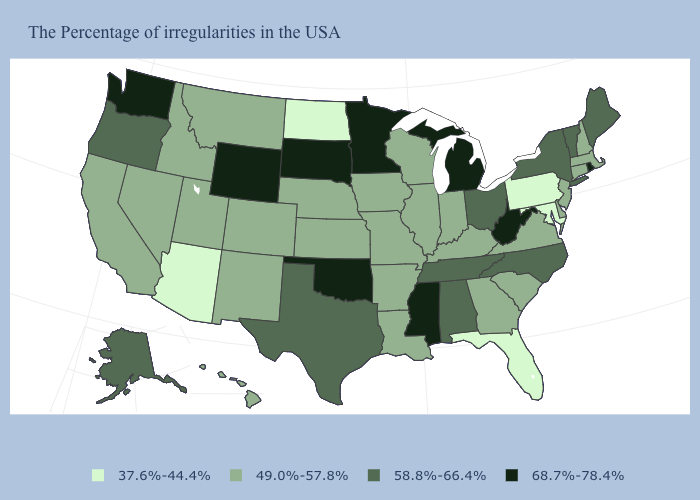What is the value of South Dakota?
Write a very short answer. 68.7%-78.4%. Among the states that border New Jersey , does New York have the highest value?
Short answer required. Yes. What is the highest value in the USA?
Be succinct. 68.7%-78.4%. What is the value of Vermont?
Concise answer only. 58.8%-66.4%. Name the states that have a value in the range 68.7%-78.4%?
Answer briefly. Rhode Island, West Virginia, Michigan, Mississippi, Minnesota, Oklahoma, South Dakota, Wyoming, Washington. Which states have the highest value in the USA?
Quick response, please. Rhode Island, West Virginia, Michigan, Mississippi, Minnesota, Oklahoma, South Dakota, Wyoming, Washington. Name the states that have a value in the range 49.0%-57.8%?
Be succinct. Massachusetts, New Hampshire, Connecticut, New Jersey, Delaware, Virginia, South Carolina, Georgia, Kentucky, Indiana, Wisconsin, Illinois, Louisiana, Missouri, Arkansas, Iowa, Kansas, Nebraska, Colorado, New Mexico, Utah, Montana, Idaho, Nevada, California, Hawaii. Among the states that border Maine , which have the highest value?
Write a very short answer. New Hampshire. Is the legend a continuous bar?
Give a very brief answer. No. Does Massachusetts have the same value as Oregon?
Give a very brief answer. No. Name the states that have a value in the range 49.0%-57.8%?
Write a very short answer. Massachusetts, New Hampshire, Connecticut, New Jersey, Delaware, Virginia, South Carolina, Georgia, Kentucky, Indiana, Wisconsin, Illinois, Louisiana, Missouri, Arkansas, Iowa, Kansas, Nebraska, Colorado, New Mexico, Utah, Montana, Idaho, Nevada, California, Hawaii. Does Alabama have a higher value than West Virginia?
Answer briefly. No. Is the legend a continuous bar?
Be succinct. No. Name the states that have a value in the range 58.8%-66.4%?
Keep it brief. Maine, Vermont, New York, North Carolina, Ohio, Alabama, Tennessee, Texas, Oregon, Alaska. What is the lowest value in the Northeast?
Answer briefly. 37.6%-44.4%. 